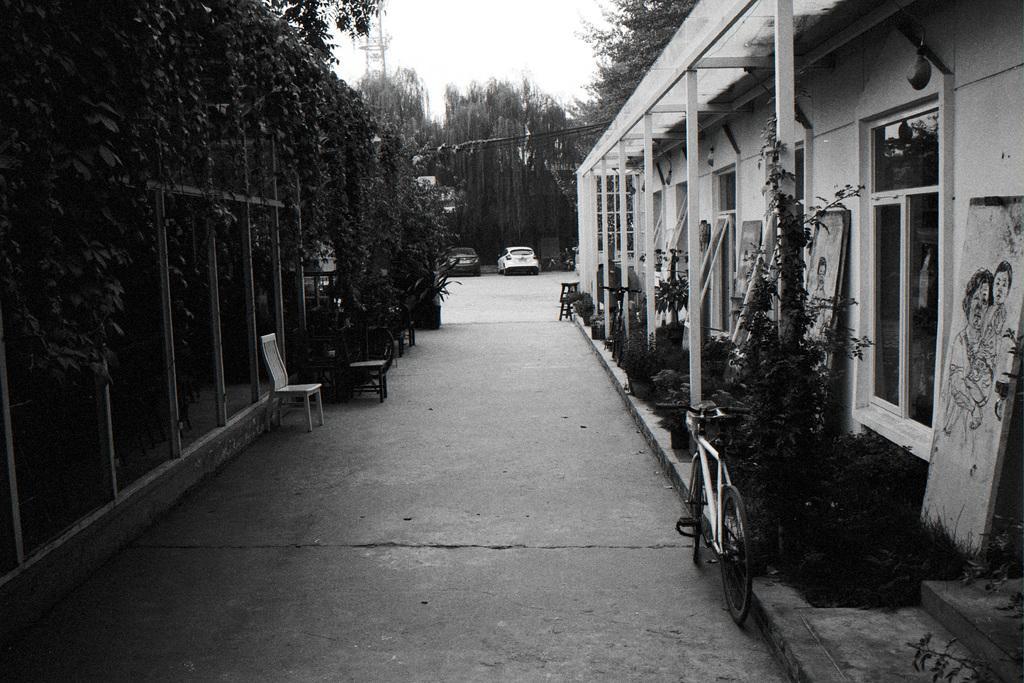Can you describe this image briefly? In this image I can see few buildings, windows, trees, vehicles, bicycles, chairs, sky, stairs and few objects. The image is black and white. 